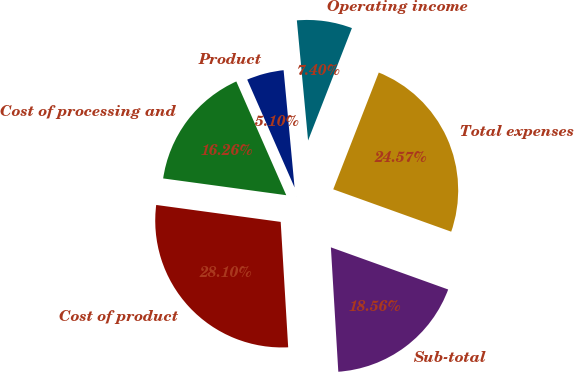Convert chart to OTSL. <chart><loc_0><loc_0><loc_500><loc_500><pie_chart><fcel>Product<fcel>Cost of processing and<fcel>Cost of product<fcel>Sub-total<fcel>Total expenses<fcel>Operating income<nl><fcel>5.1%<fcel>16.26%<fcel>28.1%<fcel>18.56%<fcel>24.57%<fcel>7.4%<nl></chart> 